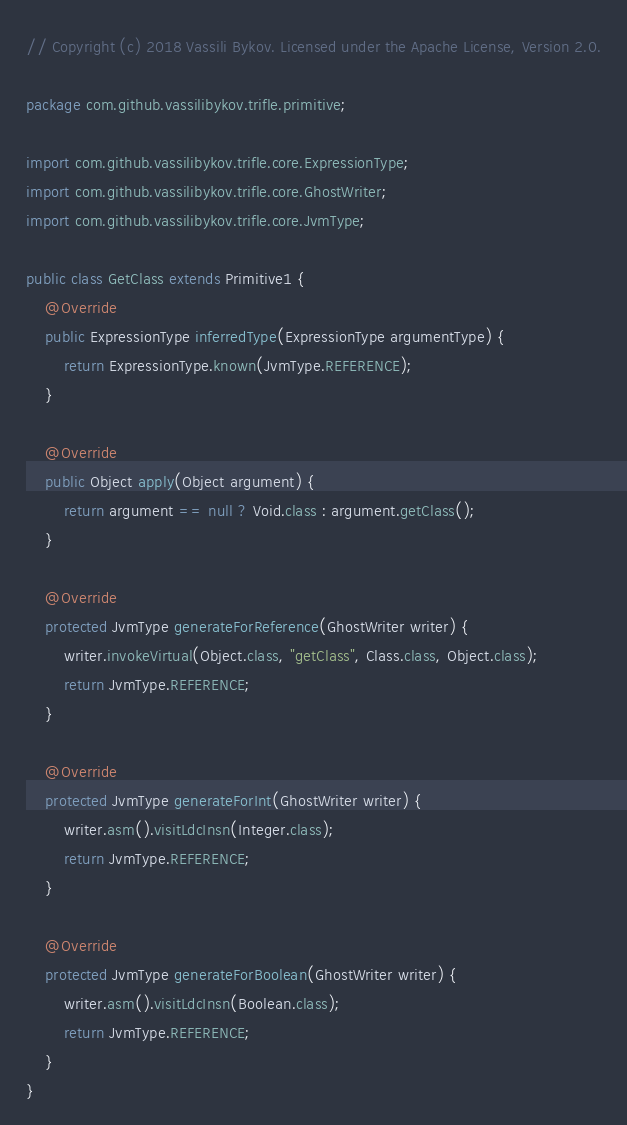<code> <loc_0><loc_0><loc_500><loc_500><_Java_>// Copyright (c) 2018 Vassili Bykov. Licensed under the Apache License, Version 2.0.

package com.github.vassilibykov.trifle.primitive;

import com.github.vassilibykov.trifle.core.ExpressionType;
import com.github.vassilibykov.trifle.core.GhostWriter;
import com.github.vassilibykov.trifle.core.JvmType;

public class GetClass extends Primitive1 {
    @Override
    public ExpressionType inferredType(ExpressionType argumentType) {
        return ExpressionType.known(JvmType.REFERENCE);
    }

    @Override
    public Object apply(Object argument) {
        return argument == null ? Void.class : argument.getClass();
    }

    @Override
    protected JvmType generateForReference(GhostWriter writer) {
        writer.invokeVirtual(Object.class, "getClass", Class.class, Object.class);
        return JvmType.REFERENCE;
    }

    @Override
    protected JvmType generateForInt(GhostWriter writer) {
        writer.asm().visitLdcInsn(Integer.class);
        return JvmType.REFERENCE;
    }

    @Override
    protected JvmType generateForBoolean(GhostWriter writer) {
        writer.asm().visitLdcInsn(Boolean.class);
        return JvmType.REFERENCE;
    }
}
</code> 